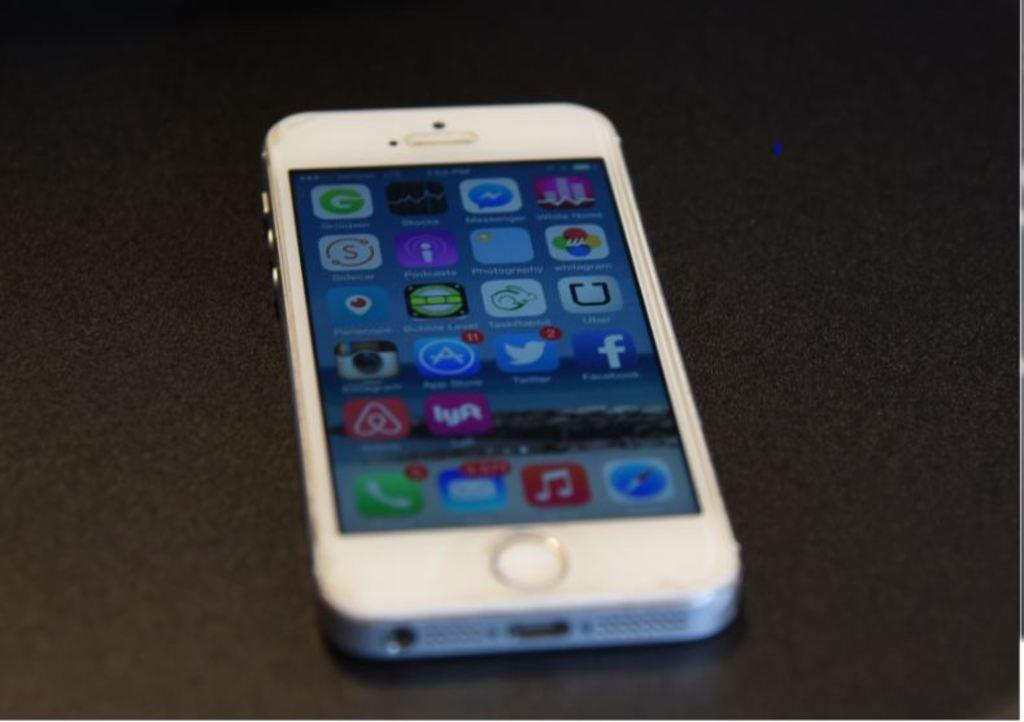<image>
Provide a brief description of the given image. A white cell phone displaying a variety of apps including Facebook and Twitter 